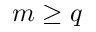Convert formula to latex. <formula><loc_0><loc_0><loc_500><loc_500>m \geq q</formula> 